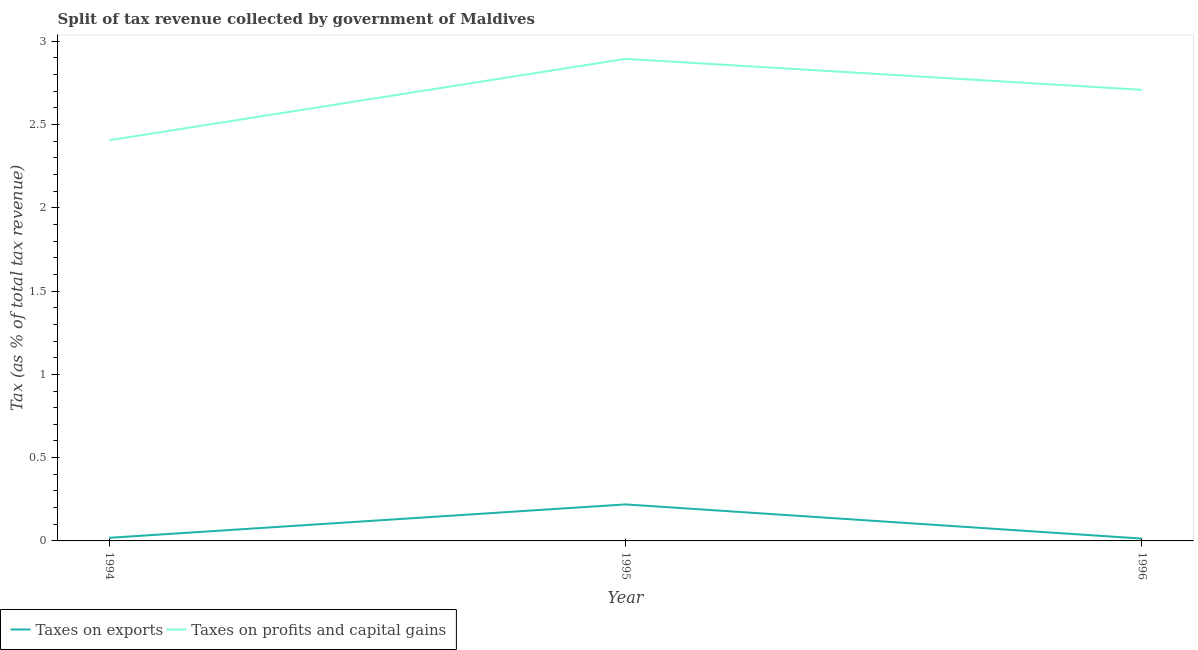What is the percentage of revenue obtained from taxes on profits and capital gains in 1994?
Offer a very short reply. 2.41. Across all years, what is the maximum percentage of revenue obtained from taxes on exports?
Your answer should be compact. 0.22. Across all years, what is the minimum percentage of revenue obtained from taxes on profits and capital gains?
Give a very brief answer. 2.41. In which year was the percentage of revenue obtained from taxes on profits and capital gains minimum?
Your answer should be compact. 1994. What is the total percentage of revenue obtained from taxes on profits and capital gains in the graph?
Your answer should be very brief. 8.01. What is the difference between the percentage of revenue obtained from taxes on profits and capital gains in 1994 and that in 1996?
Keep it short and to the point. -0.3. What is the difference between the percentage of revenue obtained from taxes on exports in 1994 and the percentage of revenue obtained from taxes on profits and capital gains in 1995?
Provide a short and direct response. -2.88. What is the average percentage of revenue obtained from taxes on exports per year?
Provide a short and direct response. 0.08. In the year 1995, what is the difference between the percentage of revenue obtained from taxes on profits and capital gains and percentage of revenue obtained from taxes on exports?
Give a very brief answer. 2.68. What is the ratio of the percentage of revenue obtained from taxes on profits and capital gains in 1994 to that in 1995?
Your response must be concise. 0.83. Is the difference between the percentage of revenue obtained from taxes on exports in 1995 and 1996 greater than the difference between the percentage of revenue obtained from taxes on profits and capital gains in 1995 and 1996?
Give a very brief answer. Yes. What is the difference between the highest and the second highest percentage of revenue obtained from taxes on profits and capital gains?
Provide a succinct answer. 0.19. What is the difference between the highest and the lowest percentage of revenue obtained from taxes on exports?
Your answer should be very brief. 0.21. Is the sum of the percentage of revenue obtained from taxes on profits and capital gains in 1994 and 1995 greater than the maximum percentage of revenue obtained from taxes on exports across all years?
Make the answer very short. Yes. Does the percentage of revenue obtained from taxes on exports monotonically increase over the years?
Offer a terse response. No. How many lines are there?
Offer a terse response. 2. Does the graph contain any zero values?
Provide a short and direct response. No. Does the graph contain grids?
Your answer should be compact. No. Where does the legend appear in the graph?
Your response must be concise. Bottom left. What is the title of the graph?
Offer a terse response. Split of tax revenue collected by government of Maldives. What is the label or title of the X-axis?
Your answer should be very brief. Year. What is the label or title of the Y-axis?
Provide a short and direct response. Tax (as % of total tax revenue). What is the Tax (as % of total tax revenue) in Taxes on exports in 1994?
Make the answer very short. 0.02. What is the Tax (as % of total tax revenue) in Taxes on profits and capital gains in 1994?
Make the answer very short. 2.41. What is the Tax (as % of total tax revenue) of Taxes on exports in 1995?
Offer a very short reply. 0.22. What is the Tax (as % of total tax revenue) of Taxes on profits and capital gains in 1995?
Ensure brevity in your answer.  2.89. What is the Tax (as % of total tax revenue) in Taxes on exports in 1996?
Offer a very short reply. 0.01. What is the Tax (as % of total tax revenue) of Taxes on profits and capital gains in 1996?
Your answer should be compact. 2.71. Across all years, what is the maximum Tax (as % of total tax revenue) in Taxes on exports?
Give a very brief answer. 0.22. Across all years, what is the maximum Tax (as % of total tax revenue) in Taxes on profits and capital gains?
Your answer should be compact. 2.89. Across all years, what is the minimum Tax (as % of total tax revenue) in Taxes on exports?
Your response must be concise. 0.01. Across all years, what is the minimum Tax (as % of total tax revenue) in Taxes on profits and capital gains?
Provide a short and direct response. 2.41. What is the total Tax (as % of total tax revenue) in Taxes on exports in the graph?
Your answer should be very brief. 0.25. What is the total Tax (as % of total tax revenue) in Taxes on profits and capital gains in the graph?
Provide a succinct answer. 8.01. What is the difference between the Tax (as % of total tax revenue) of Taxes on exports in 1994 and that in 1995?
Provide a succinct answer. -0.2. What is the difference between the Tax (as % of total tax revenue) in Taxes on profits and capital gains in 1994 and that in 1995?
Your answer should be very brief. -0.49. What is the difference between the Tax (as % of total tax revenue) in Taxes on exports in 1994 and that in 1996?
Offer a very short reply. 0. What is the difference between the Tax (as % of total tax revenue) of Taxes on profits and capital gains in 1994 and that in 1996?
Offer a very short reply. -0.3. What is the difference between the Tax (as % of total tax revenue) of Taxes on exports in 1995 and that in 1996?
Make the answer very short. 0.21. What is the difference between the Tax (as % of total tax revenue) of Taxes on profits and capital gains in 1995 and that in 1996?
Give a very brief answer. 0.19. What is the difference between the Tax (as % of total tax revenue) in Taxes on exports in 1994 and the Tax (as % of total tax revenue) in Taxes on profits and capital gains in 1995?
Provide a succinct answer. -2.88. What is the difference between the Tax (as % of total tax revenue) in Taxes on exports in 1994 and the Tax (as % of total tax revenue) in Taxes on profits and capital gains in 1996?
Provide a short and direct response. -2.69. What is the difference between the Tax (as % of total tax revenue) in Taxes on exports in 1995 and the Tax (as % of total tax revenue) in Taxes on profits and capital gains in 1996?
Give a very brief answer. -2.49. What is the average Tax (as % of total tax revenue) in Taxes on exports per year?
Offer a very short reply. 0.08. What is the average Tax (as % of total tax revenue) in Taxes on profits and capital gains per year?
Give a very brief answer. 2.67. In the year 1994, what is the difference between the Tax (as % of total tax revenue) in Taxes on exports and Tax (as % of total tax revenue) in Taxes on profits and capital gains?
Provide a short and direct response. -2.39. In the year 1995, what is the difference between the Tax (as % of total tax revenue) of Taxes on exports and Tax (as % of total tax revenue) of Taxes on profits and capital gains?
Your answer should be very brief. -2.68. In the year 1996, what is the difference between the Tax (as % of total tax revenue) of Taxes on exports and Tax (as % of total tax revenue) of Taxes on profits and capital gains?
Make the answer very short. -2.69. What is the ratio of the Tax (as % of total tax revenue) in Taxes on exports in 1994 to that in 1995?
Keep it short and to the point. 0.09. What is the ratio of the Tax (as % of total tax revenue) in Taxes on profits and capital gains in 1994 to that in 1995?
Offer a very short reply. 0.83. What is the ratio of the Tax (as % of total tax revenue) of Taxes on exports in 1994 to that in 1996?
Provide a succinct answer. 1.33. What is the ratio of the Tax (as % of total tax revenue) in Taxes on profits and capital gains in 1994 to that in 1996?
Offer a terse response. 0.89. What is the ratio of the Tax (as % of total tax revenue) in Taxes on exports in 1995 to that in 1996?
Your answer should be very brief. 15.64. What is the ratio of the Tax (as % of total tax revenue) of Taxes on profits and capital gains in 1995 to that in 1996?
Provide a succinct answer. 1.07. What is the difference between the highest and the second highest Tax (as % of total tax revenue) in Taxes on exports?
Give a very brief answer. 0.2. What is the difference between the highest and the second highest Tax (as % of total tax revenue) of Taxes on profits and capital gains?
Make the answer very short. 0.19. What is the difference between the highest and the lowest Tax (as % of total tax revenue) in Taxes on exports?
Provide a succinct answer. 0.21. What is the difference between the highest and the lowest Tax (as % of total tax revenue) in Taxes on profits and capital gains?
Make the answer very short. 0.49. 